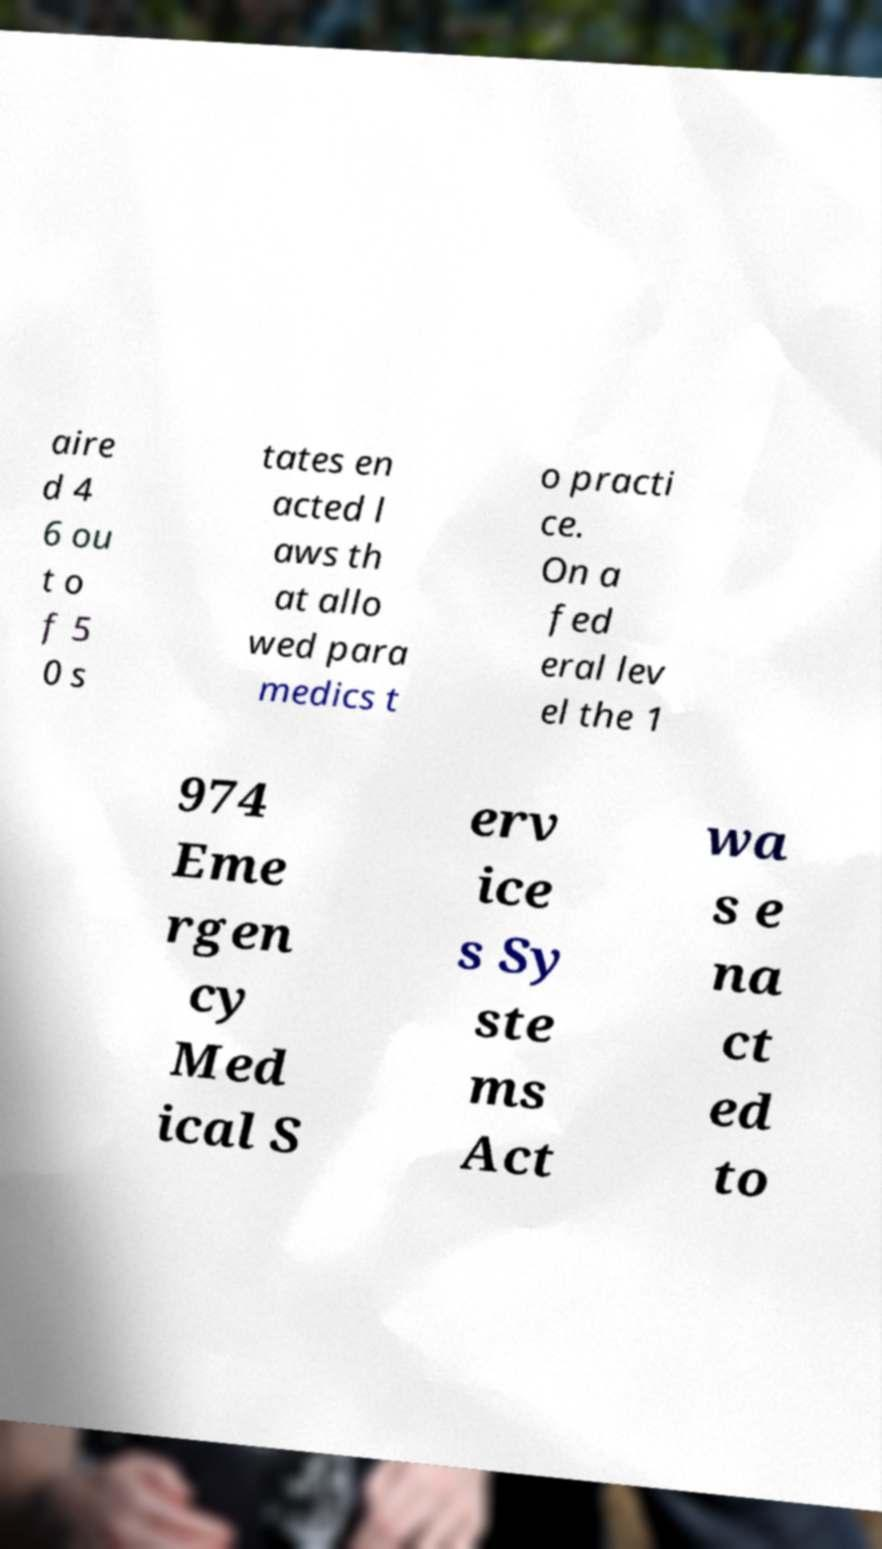For documentation purposes, I need the text within this image transcribed. Could you provide that? aire d 4 6 ou t o f 5 0 s tates en acted l aws th at allo wed para medics t o practi ce. On a fed eral lev el the 1 974 Eme rgen cy Med ical S erv ice s Sy ste ms Act wa s e na ct ed to 